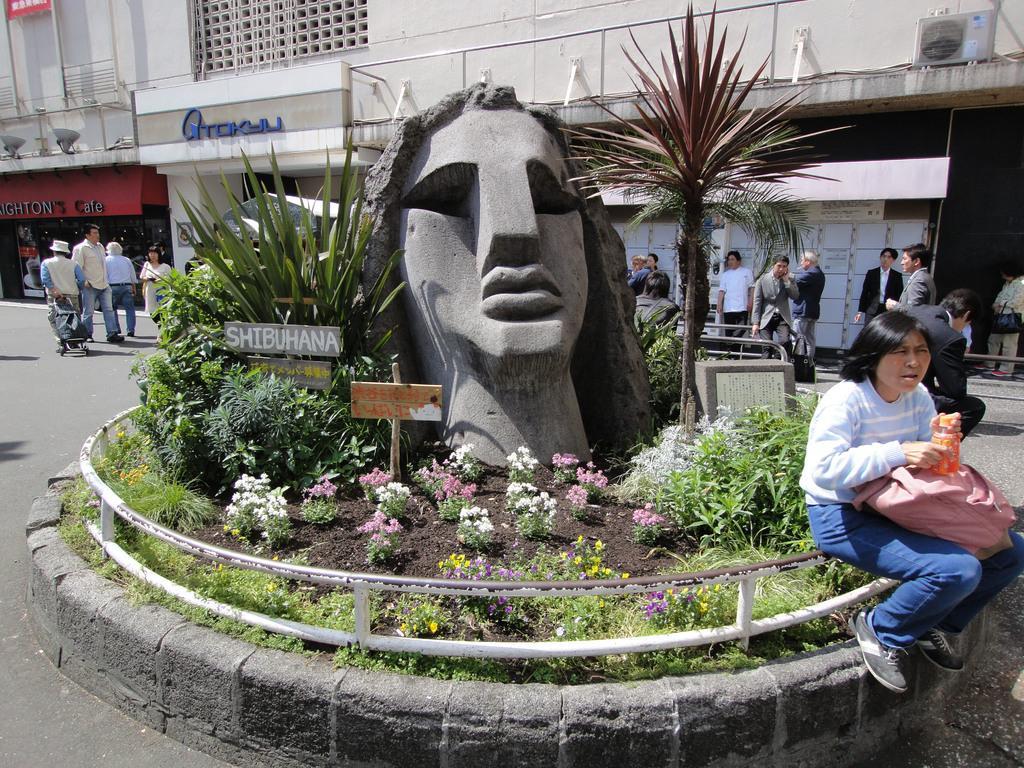How would you summarize this image in a sentence or two? This image is clicked outside. In the middle there is a sculpture. To the right, the woman sitting is wearing blue jeans and holding a pink color bag. There are many people in this image. In the background, there are buildings and shops. At the bottom, there is road. In the middle there are plants. 